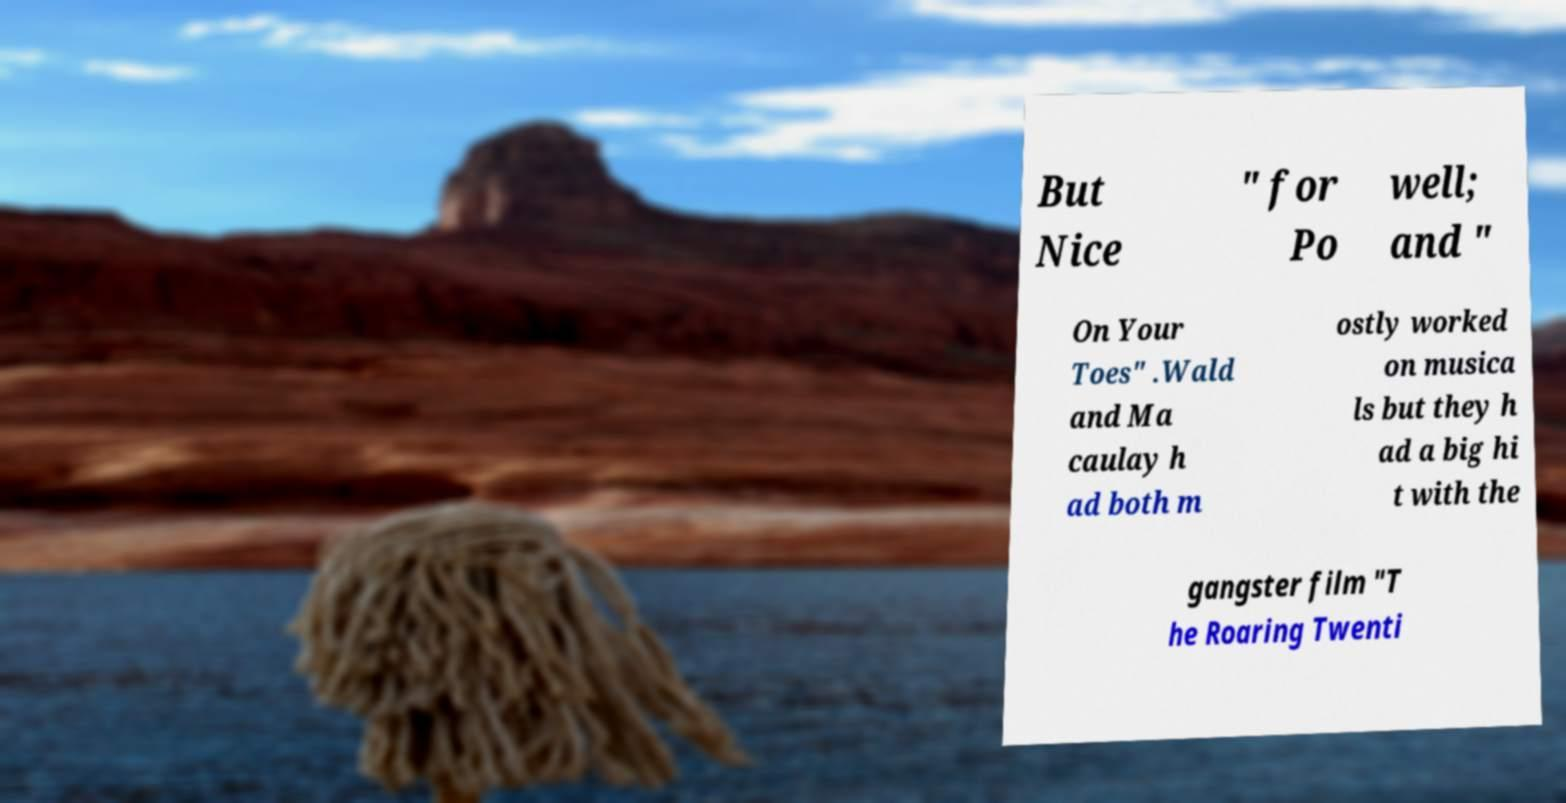Please identify and transcribe the text found in this image. But Nice " for Po well; and " On Your Toes" .Wald and Ma caulay h ad both m ostly worked on musica ls but they h ad a big hi t with the gangster film "T he Roaring Twenti 